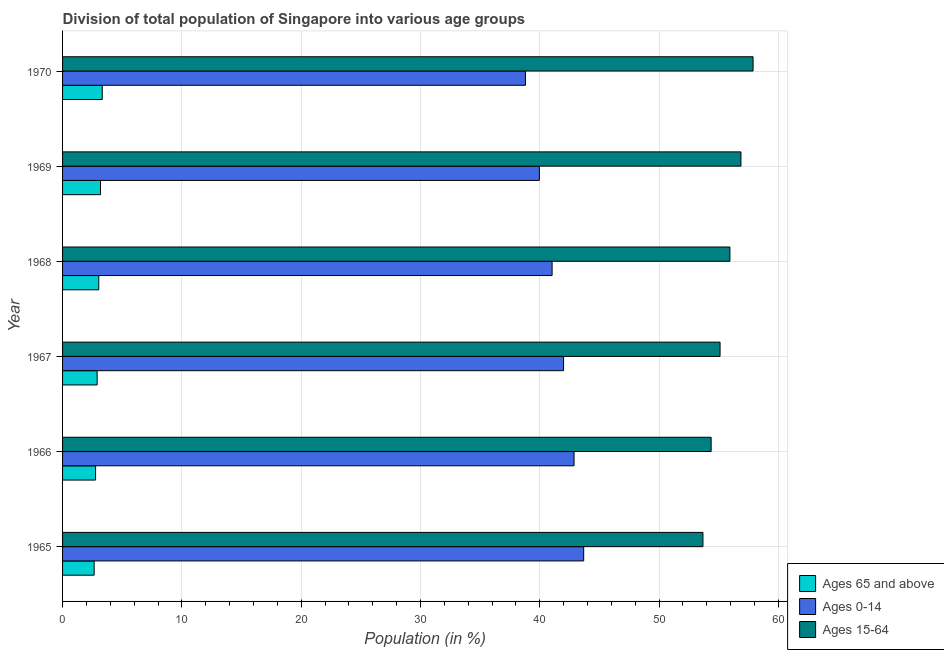How many groups of bars are there?
Give a very brief answer. 6. How many bars are there on the 1st tick from the top?
Your response must be concise. 3. What is the label of the 5th group of bars from the top?
Offer a terse response. 1966. What is the percentage of population within the age-group of 65 and above in 1970?
Make the answer very short. 3.33. Across all years, what is the maximum percentage of population within the age-group of 65 and above?
Offer a terse response. 3.33. Across all years, what is the minimum percentage of population within the age-group 0-14?
Your answer should be compact. 38.8. In which year was the percentage of population within the age-group 15-64 maximum?
Provide a succinct answer. 1970. In which year was the percentage of population within the age-group 0-14 minimum?
Offer a terse response. 1970. What is the total percentage of population within the age-group 0-14 in the graph?
Provide a succinct answer. 248.33. What is the difference between the percentage of population within the age-group 15-64 in 1965 and that in 1967?
Offer a very short reply. -1.44. What is the difference between the percentage of population within the age-group 0-14 in 1967 and the percentage of population within the age-group 15-64 in 1966?
Provide a short and direct response. -12.37. What is the average percentage of population within the age-group 15-64 per year?
Your response must be concise. 55.64. In the year 1967, what is the difference between the percentage of population within the age-group 0-14 and percentage of population within the age-group of 65 and above?
Provide a succinct answer. 39.09. What is the ratio of the percentage of population within the age-group of 65 and above in 1965 to that in 1970?
Your answer should be very brief. 0.8. Is the difference between the percentage of population within the age-group 0-14 in 1968 and 1970 greater than the difference between the percentage of population within the age-group 15-64 in 1968 and 1970?
Your response must be concise. Yes. What is the difference between the highest and the second highest percentage of population within the age-group 0-14?
Your answer should be compact. 0.81. What is the difference between the highest and the lowest percentage of population within the age-group 0-14?
Make the answer very short. 4.88. What does the 2nd bar from the top in 1965 represents?
Your answer should be very brief. Ages 0-14. What does the 3rd bar from the bottom in 1970 represents?
Offer a terse response. Ages 15-64. How many bars are there?
Make the answer very short. 18. How many years are there in the graph?
Offer a very short reply. 6. Does the graph contain grids?
Keep it short and to the point. Yes. Where does the legend appear in the graph?
Offer a terse response. Bottom right. How many legend labels are there?
Ensure brevity in your answer.  3. What is the title of the graph?
Your response must be concise. Division of total population of Singapore into various age groups
. Does "Labor Tax" appear as one of the legend labels in the graph?
Provide a short and direct response. No. What is the label or title of the X-axis?
Provide a succinct answer. Population (in %). What is the Population (in %) in Ages 65 and above in 1965?
Give a very brief answer. 2.65. What is the Population (in %) of Ages 0-14 in 1965?
Make the answer very short. 43.68. What is the Population (in %) of Ages 15-64 in 1965?
Provide a short and direct response. 53.67. What is the Population (in %) in Ages 65 and above in 1966?
Your answer should be compact. 2.77. What is the Population (in %) in Ages 0-14 in 1966?
Your answer should be compact. 42.87. What is the Population (in %) of Ages 15-64 in 1966?
Keep it short and to the point. 54.36. What is the Population (in %) of Ages 65 and above in 1967?
Keep it short and to the point. 2.9. What is the Population (in %) in Ages 0-14 in 1967?
Offer a very short reply. 41.99. What is the Population (in %) in Ages 15-64 in 1967?
Your answer should be very brief. 55.11. What is the Population (in %) in Ages 65 and above in 1968?
Your response must be concise. 3.03. What is the Population (in %) in Ages 0-14 in 1968?
Your answer should be compact. 41.03. What is the Population (in %) in Ages 15-64 in 1968?
Make the answer very short. 55.93. What is the Population (in %) of Ages 65 and above in 1969?
Provide a short and direct response. 3.18. What is the Population (in %) of Ages 0-14 in 1969?
Provide a succinct answer. 39.96. What is the Population (in %) of Ages 15-64 in 1969?
Make the answer very short. 56.86. What is the Population (in %) in Ages 65 and above in 1970?
Provide a short and direct response. 3.33. What is the Population (in %) of Ages 0-14 in 1970?
Offer a very short reply. 38.8. What is the Population (in %) of Ages 15-64 in 1970?
Provide a short and direct response. 57.88. Across all years, what is the maximum Population (in %) in Ages 65 and above?
Offer a very short reply. 3.33. Across all years, what is the maximum Population (in %) in Ages 0-14?
Your response must be concise. 43.68. Across all years, what is the maximum Population (in %) in Ages 15-64?
Make the answer very short. 57.88. Across all years, what is the minimum Population (in %) in Ages 65 and above?
Offer a very short reply. 2.65. Across all years, what is the minimum Population (in %) of Ages 0-14?
Offer a terse response. 38.8. Across all years, what is the minimum Population (in %) of Ages 15-64?
Offer a terse response. 53.67. What is the total Population (in %) in Ages 65 and above in the graph?
Offer a terse response. 17.85. What is the total Population (in %) of Ages 0-14 in the graph?
Provide a short and direct response. 248.33. What is the total Population (in %) in Ages 15-64 in the graph?
Your answer should be compact. 333.81. What is the difference between the Population (in %) of Ages 65 and above in 1965 and that in 1966?
Ensure brevity in your answer.  -0.12. What is the difference between the Population (in %) of Ages 0-14 in 1965 and that in 1966?
Provide a short and direct response. 0.81. What is the difference between the Population (in %) of Ages 15-64 in 1965 and that in 1966?
Your answer should be compact. -0.69. What is the difference between the Population (in %) in Ages 65 and above in 1965 and that in 1967?
Keep it short and to the point. -0.25. What is the difference between the Population (in %) of Ages 0-14 in 1965 and that in 1967?
Offer a very short reply. 1.69. What is the difference between the Population (in %) of Ages 15-64 in 1965 and that in 1967?
Make the answer very short. -1.44. What is the difference between the Population (in %) of Ages 65 and above in 1965 and that in 1968?
Your answer should be compact. -0.39. What is the difference between the Population (in %) in Ages 0-14 in 1965 and that in 1968?
Make the answer very short. 2.65. What is the difference between the Population (in %) of Ages 15-64 in 1965 and that in 1968?
Offer a very short reply. -2.26. What is the difference between the Population (in %) in Ages 65 and above in 1965 and that in 1969?
Ensure brevity in your answer.  -0.53. What is the difference between the Population (in %) in Ages 0-14 in 1965 and that in 1969?
Keep it short and to the point. 3.72. What is the difference between the Population (in %) in Ages 15-64 in 1965 and that in 1969?
Your answer should be very brief. -3.18. What is the difference between the Population (in %) in Ages 65 and above in 1965 and that in 1970?
Offer a terse response. -0.68. What is the difference between the Population (in %) in Ages 0-14 in 1965 and that in 1970?
Provide a short and direct response. 4.88. What is the difference between the Population (in %) in Ages 15-64 in 1965 and that in 1970?
Provide a short and direct response. -4.2. What is the difference between the Population (in %) in Ages 65 and above in 1966 and that in 1967?
Offer a very short reply. -0.13. What is the difference between the Population (in %) in Ages 0-14 in 1966 and that in 1967?
Your response must be concise. 0.88. What is the difference between the Population (in %) in Ages 15-64 in 1966 and that in 1967?
Provide a succinct answer. -0.75. What is the difference between the Population (in %) of Ages 65 and above in 1966 and that in 1968?
Offer a terse response. -0.27. What is the difference between the Population (in %) in Ages 0-14 in 1966 and that in 1968?
Offer a terse response. 1.84. What is the difference between the Population (in %) of Ages 15-64 in 1966 and that in 1968?
Offer a terse response. -1.57. What is the difference between the Population (in %) of Ages 65 and above in 1966 and that in 1969?
Make the answer very short. -0.41. What is the difference between the Population (in %) in Ages 0-14 in 1966 and that in 1969?
Ensure brevity in your answer.  2.91. What is the difference between the Population (in %) in Ages 15-64 in 1966 and that in 1969?
Offer a terse response. -2.5. What is the difference between the Population (in %) of Ages 65 and above in 1966 and that in 1970?
Ensure brevity in your answer.  -0.56. What is the difference between the Population (in %) of Ages 0-14 in 1966 and that in 1970?
Offer a terse response. 4.07. What is the difference between the Population (in %) of Ages 15-64 in 1966 and that in 1970?
Offer a terse response. -3.52. What is the difference between the Population (in %) of Ages 65 and above in 1967 and that in 1968?
Give a very brief answer. -0.14. What is the difference between the Population (in %) in Ages 0-14 in 1967 and that in 1968?
Make the answer very short. 0.96. What is the difference between the Population (in %) of Ages 15-64 in 1967 and that in 1968?
Provide a short and direct response. -0.82. What is the difference between the Population (in %) in Ages 65 and above in 1967 and that in 1969?
Your answer should be very brief. -0.28. What is the difference between the Population (in %) of Ages 0-14 in 1967 and that in 1969?
Your answer should be compact. 2.03. What is the difference between the Population (in %) in Ages 15-64 in 1967 and that in 1969?
Provide a short and direct response. -1.75. What is the difference between the Population (in %) of Ages 65 and above in 1967 and that in 1970?
Offer a very short reply. -0.43. What is the difference between the Population (in %) of Ages 0-14 in 1967 and that in 1970?
Your answer should be compact. 3.2. What is the difference between the Population (in %) of Ages 15-64 in 1967 and that in 1970?
Give a very brief answer. -2.77. What is the difference between the Population (in %) in Ages 65 and above in 1968 and that in 1969?
Your answer should be very brief. -0.14. What is the difference between the Population (in %) in Ages 0-14 in 1968 and that in 1969?
Your answer should be compact. 1.07. What is the difference between the Population (in %) in Ages 15-64 in 1968 and that in 1969?
Ensure brevity in your answer.  -0.93. What is the difference between the Population (in %) in Ages 65 and above in 1968 and that in 1970?
Provide a succinct answer. -0.29. What is the difference between the Population (in %) of Ages 0-14 in 1968 and that in 1970?
Make the answer very short. 2.23. What is the difference between the Population (in %) of Ages 15-64 in 1968 and that in 1970?
Ensure brevity in your answer.  -1.94. What is the difference between the Population (in %) in Ages 65 and above in 1969 and that in 1970?
Give a very brief answer. -0.15. What is the difference between the Population (in %) in Ages 0-14 in 1969 and that in 1970?
Your answer should be compact. 1.17. What is the difference between the Population (in %) in Ages 15-64 in 1969 and that in 1970?
Your response must be concise. -1.02. What is the difference between the Population (in %) of Ages 65 and above in 1965 and the Population (in %) of Ages 0-14 in 1966?
Offer a very short reply. -40.22. What is the difference between the Population (in %) in Ages 65 and above in 1965 and the Population (in %) in Ages 15-64 in 1966?
Offer a terse response. -51.71. What is the difference between the Population (in %) in Ages 0-14 in 1965 and the Population (in %) in Ages 15-64 in 1966?
Keep it short and to the point. -10.68. What is the difference between the Population (in %) in Ages 65 and above in 1965 and the Population (in %) in Ages 0-14 in 1967?
Offer a very short reply. -39.35. What is the difference between the Population (in %) of Ages 65 and above in 1965 and the Population (in %) of Ages 15-64 in 1967?
Ensure brevity in your answer.  -52.46. What is the difference between the Population (in %) in Ages 0-14 in 1965 and the Population (in %) in Ages 15-64 in 1967?
Provide a succinct answer. -11.43. What is the difference between the Population (in %) in Ages 65 and above in 1965 and the Population (in %) in Ages 0-14 in 1968?
Your answer should be compact. -38.38. What is the difference between the Population (in %) of Ages 65 and above in 1965 and the Population (in %) of Ages 15-64 in 1968?
Your response must be concise. -53.29. What is the difference between the Population (in %) of Ages 0-14 in 1965 and the Population (in %) of Ages 15-64 in 1968?
Your answer should be compact. -12.26. What is the difference between the Population (in %) of Ages 65 and above in 1965 and the Population (in %) of Ages 0-14 in 1969?
Give a very brief answer. -37.32. What is the difference between the Population (in %) of Ages 65 and above in 1965 and the Population (in %) of Ages 15-64 in 1969?
Offer a terse response. -54.21. What is the difference between the Population (in %) of Ages 0-14 in 1965 and the Population (in %) of Ages 15-64 in 1969?
Provide a succinct answer. -13.18. What is the difference between the Population (in %) of Ages 65 and above in 1965 and the Population (in %) of Ages 0-14 in 1970?
Offer a terse response. -36.15. What is the difference between the Population (in %) of Ages 65 and above in 1965 and the Population (in %) of Ages 15-64 in 1970?
Give a very brief answer. -55.23. What is the difference between the Population (in %) of Ages 0-14 in 1965 and the Population (in %) of Ages 15-64 in 1970?
Your answer should be compact. -14.2. What is the difference between the Population (in %) of Ages 65 and above in 1966 and the Population (in %) of Ages 0-14 in 1967?
Provide a succinct answer. -39.23. What is the difference between the Population (in %) of Ages 65 and above in 1966 and the Population (in %) of Ages 15-64 in 1967?
Provide a succinct answer. -52.34. What is the difference between the Population (in %) in Ages 0-14 in 1966 and the Population (in %) in Ages 15-64 in 1967?
Ensure brevity in your answer.  -12.24. What is the difference between the Population (in %) of Ages 65 and above in 1966 and the Population (in %) of Ages 0-14 in 1968?
Your answer should be very brief. -38.26. What is the difference between the Population (in %) in Ages 65 and above in 1966 and the Population (in %) in Ages 15-64 in 1968?
Keep it short and to the point. -53.17. What is the difference between the Population (in %) in Ages 0-14 in 1966 and the Population (in %) in Ages 15-64 in 1968?
Your response must be concise. -13.06. What is the difference between the Population (in %) in Ages 65 and above in 1966 and the Population (in %) in Ages 0-14 in 1969?
Give a very brief answer. -37.19. What is the difference between the Population (in %) of Ages 65 and above in 1966 and the Population (in %) of Ages 15-64 in 1969?
Your answer should be compact. -54.09. What is the difference between the Population (in %) of Ages 0-14 in 1966 and the Population (in %) of Ages 15-64 in 1969?
Give a very brief answer. -13.99. What is the difference between the Population (in %) in Ages 65 and above in 1966 and the Population (in %) in Ages 0-14 in 1970?
Keep it short and to the point. -36.03. What is the difference between the Population (in %) of Ages 65 and above in 1966 and the Population (in %) of Ages 15-64 in 1970?
Provide a short and direct response. -55.11. What is the difference between the Population (in %) of Ages 0-14 in 1966 and the Population (in %) of Ages 15-64 in 1970?
Make the answer very short. -15. What is the difference between the Population (in %) in Ages 65 and above in 1967 and the Population (in %) in Ages 0-14 in 1968?
Your response must be concise. -38.13. What is the difference between the Population (in %) of Ages 65 and above in 1967 and the Population (in %) of Ages 15-64 in 1968?
Your answer should be compact. -53.04. What is the difference between the Population (in %) of Ages 0-14 in 1967 and the Population (in %) of Ages 15-64 in 1968?
Offer a very short reply. -13.94. What is the difference between the Population (in %) of Ages 65 and above in 1967 and the Population (in %) of Ages 0-14 in 1969?
Your answer should be very brief. -37.07. What is the difference between the Population (in %) in Ages 65 and above in 1967 and the Population (in %) in Ages 15-64 in 1969?
Offer a terse response. -53.96. What is the difference between the Population (in %) in Ages 0-14 in 1967 and the Population (in %) in Ages 15-64 in 1969?
Provide a succinct answer. -14.87. What is the difference between the Population (in %) in Ages 65 and above in 1967 and the Population (in %) in Ages 0-14 in 1970?
Offer a terse response. -35.9. What is the difference between the Population (in %) of Ages 65 and above in 1967 and the Population (in %) of Ages 15-64 in 1970?
Your response must be concise. -54.98. What is the difference between the Population (in %) in Ages 0-14 in 1967 and the Population (in %) in Ages 15-64 in 1970?
Offer a terse response. -15.88. What is the difference between the Population (in %) of Ages 65 and above in 1968 and the Population (in %) of Ages 0-14 in 1969?
Provide a succinct answer. -36.93. What is the difference between the Population (in %) of Ages 65 and above in 1968 and the Population (in %) of Ages 15-64 in 1969?
Keep it short and to the point. -53.82. What is the difference between the Population (in %) of Ages 0-14 in 1968 and the Population (in %) of Ages 15-64 in 1969?
Offer a very short reply. -15.83. What is the difference between the Population (in %) in Ages 65 and above in 1968 and the Population (in %) in Ages 0-14 in 1970?
Provide a short and direct response. -35.76. What is the difference between the Population (in %) of Ages 65 and above in 1968 and the Population (in %) of Ages 15-64 in 1970?
Offer a terse response. -54.84. What is the difference between the Population (in %) of Ages 0-14 in 1968 and the Population (in %) of Ages 15-64 in 1970?
Keep it short and to the point. -16.84. What is the difference between the Population (in %) in Ages 65 and above in 1969 and the Population (in %) in Ages 0-14 in 1970?
Give a very brief answer. -35.62. What is the difference between the Population (in %) in Ages 65 and above in 1969 and the Population (in %) in Ages 15-64 in 1970?
Make the answer very short. -54.7. What is the difference between the Population (in %) of Ages 0-14 in 1969 and the Population (in %) of Ages 15-64 in 1970?
Your answer should be very brief. -17.91. What is the average Population (in %) of Ages 65 and above per year?
Provide a succinct answer. 2.98. What is the average Population (in %) in Ages 0-14 per year?
Provide a succinct answer. 41.39. What is the average Population (in %) of Ages 15-64 per year?
Keep it short and to the point. 55.64. In the year 1965, what is the difference between the Population (in %) of Ages 65 and above and Population (in %) of Ages 0-14?
Ensure brevity in your answer.  -41.03. In the year 1965, what is the difference between the Population (in %) of Ages 65 and above and Population (in %) of Ages 15-64?
Your answer should be compact. -51.03. In the year 1965, what is the difference between the Population (in %) of Ages 0-14 and Population (in %) of Ages 15-64?
Your answer should be compact. -10. In the year 1966, what is the difference between the Population (in %) of Ages 65 and above and Population (in %) of Ages 0-14?
Provide a short and direct response. -40.1. In the year 1966, what is the difference between the Population (in %) in Ages 65 and above and Population (in %) in Ages 15-64?
Provide a succinct answer. -51.59. In the year 1966, what is the difference between the Population (in %) of Ages 0-14 and Population (in %) of Ages 15-64?
Your answer should be compact. -11.49. In the year 1967, what is the difference between the Population (in %) of Ages 65 and above and Population (in %) of Ages 0-14?
Your answer should be compact. -39.1. In the year 1967, what is the difference between the Population (in %) of Ages 65 and above and Population (in %) of Ages 15-64?
Your answer should be very brief. -52.21. In the year 1967, what is the difference between the Population (in %) in Ages 0-14 and Population (in %) in Ages 15-64?
Give a very brief answer. -13.12. In the year 1968, what is the difference between the Population (in %) of Ages 65 and above and Population (in %) of Ages 0-14?
Provide a short and direct response. -38. In the year 1968, what is the difference between the Population (in %) of Ages 65 and above and Population (in %) of Ages 15-64?
Provide a short and direct response. -52.9. In the year 1968, what is the difference between the Population (in %) in Ages 0-14 and Population (in %) in Ages 15-64?
Keep it short and to the point. -14.9. In the year 1969, what is the difference between the Population (in %) in Ages 65 and above and Population (in %) in Ages 0-14?
Your answer should be compact. -36.78. In the year 1969, what is the difference between the Population (in %) in Ages 65 and above and Population (in %) in Ages 15-64?
Your answer should be compact. -53.68. In the year 1969, what is the difference between the Population (in %) in Ages 0-14 and Population (in %) in Ages 15-64?
Offer a terse response. -16.9. In the year 1970, what is the difference between the Population (in %) of Ages 65 and above and Population (in %) of Ages 0-14?
Provide a succinct answer. -35.47. In the year 1970, what is the difference between the Population (in %) of Ages 65 and above and Population (in %) of Ages 15-64?
Your answer should be compact. -54.55. In the year 1970, what is the difference between the Population (in %) in Ages 0-14 and Population (in %) in Ages 15-64?
Make the answer very short. -19.08. What is the ratio of the Population (in %) of Ages 65 and above in 1965 to that in 1966?
Make the answer very short. 0.96. What is the ratio of the Population (in %) of Ages 0-14 in 1965 to that in 1966?
Your answer should be compact. 1.02. What is the ratio of the Population (in %) in Ages 15-64 in 1965 to that in 1966?
Provide a succinct answer. 0.99. What is the ratio of the Population (in %) in Ages 65 and above in 1965 to that in 1967?
Provide a succinct answer. 0.91. What is the ratio of the Population (in %) in Ages 0-14 in 1965 to that in 1967?
Keep it short and to the point. 1.04. What is the ratio of the Population (in %) of Ages 65 and above in 1965 to that in 1968?
Ensure brevity in your answer.  0.87. What is the ratio of the Population (in %) of Ages 0-14 in 1965 to that in 1968?
Ensure brevity in your answer.  1.06. What is the ratio of the Population (in %) of Ages 15-64 in 1965 to that in 1968?
Your response must be concise. 0.96. What is the ratio of the Population (in %) of Ages 65 and above in 1965 to that in 1969?
Ensure brevity in your answer.  0.83. What is the ratio of the Population (in %) of Ages 0-14 in 1965 to that in 1969?
Provide a short and direct response. 1.09. What is the ratio of the Population (in %) of Ages 15-64 in 1965 to that in 1969?
Offer a terse response. 0.94. What is the ratio of the Population (in %) in Ages 65 and above in 1965 to that in 1970?
Provide a short and direct response. 0.8. What is the ratio of the Population (in %) of Ages 0-14 in 1965 to that in 1970?
Offer a very short reply. 1.13. What is the ratio of the Population (in %) in Ages 15-64 in 1965 to that in 1970?
Your answer should be very brief. 0.93. What is the ratio of the Population (in %) in Ages 65 and above in 1966 to that in 1967?
Offer a terse response. 0.96. What is the ratio of the Population (in %) in Ages 0-14 in 1966 to that in 1967?
Your answer should be compact. 1.02. What is the ratio of the Population (in %) of Ages 15-64 in 1966 to that in 1967?
Your answer should be compact. 0.99. What is the ratio of the Population (in %) of Ages 65 and above in 1966 to that in 1968?
Provide a succinct answer. 0.91. What is the ratio of the Population (in %) of Ages 0-14 in 1966 to that in 1968?
Make the answer very short. 1.04. What is the ratio of the Population (in %) of Ages 15-64 in 1966 to that in 1968?
Give a very brief answer. 0.97. What is the ratio of the Population (in %) in Ages 65 and above in 1966 to that in 1969?
Keep it short and to the point. 0.87. What is the ratio of the Population (in %) of Ages 0-14 in 1966 to that in 1969?
Your answer should be compact. 1.07. What is the ratio of the Population (in %) of Ages 15-64 in 1966 to that in 1969?
Your response must be concise. 0.96. What is the ratio of the Population (in %) in Ages 65 and above in 1966 to that in 1970?
Ensure brevity in your answer.  0.83. What is the ratio of the Population (in %) in Ages 0-14 in 1966 to that in 1970?
Ensure brevity in your answer.  1.1. What is the ratio of the Population (in %) of Ages 15-64 in 1966 to that in 1970?
Your answer should be very brief. 0.94. What is the ratio of the Population (in %) in Ages 65 and above in 1967 to that in 1968?
Your answer should be very brief. 0.95. What is the ratio of the Population (in %) in Ages 0-14 in 1967 to that in 1968?
Give a very brief answer. 1.02. What is the ratio of the Population (in %) of Ages 65 and above in 1967 to that in 1969?
Give a very brief answer. 0.91. What is the ratio of the Population (in %) in Ages 0-14 in 1967 to that in 1969?
Offer a very short reply. 1.05. What is the ratio of the Population (in %) of Ages 15-64 in 1967 to that in 1969?
Offer a very short reply. 0.97. What is the ratio of the Population (in %) in Ages 65 and above in 1967 to that in 1970?
Offer a terse response. 0.87. What is the ratio of the Population (in %) in Ages 0-14 in 1967 to that in 1970?
Provide a short and direct response. 1.08. What is the ratio of the Population (in %) of Ages 15-64 in 1967 to that in 1970?
Give a very brief answer. 0.95. What is the ratio of the Population (in %) of Ages 65 and above in 1968 to that in 1969?
Ensure brevity in your answer.  0.95. What is the ratio of the Population (in %) in Ages 0-14 in 1968 to that in 1969?
Make the answer very short. 1.03. What is the ratio of the Population (in %) of Ages 15-64 in 1968 to that in 1969?
Keep it short and to the point. 0.98. What is the ratio of the Population (in %) in Ages 65 and above in 1968 to that in 1970?
Offer a very short reply. 0.91. What is the ratio of the Population (in %) of Ages 0-14 in 1968 to that in 1970?
Your answer should be very brief. 1.06. What is the ratio of the Population (in %) in Ages 15-64 in 1968 to that in 1970?
Give a very brief answer. 0.97. What is the ratio of the Population (in %) in Ages 65 and above in 1969 to that in 1970?
Your answer should be very brief. 0.96. What is the ratio of the Population (in %) in Ages 0-14 in 1969 to that in 1970?
Provide a short and direct response. 1.03. What is the ratio of the Population (in %) in Ages 15-64 in 1969 to that in 1970?
Offer a terse response. 0.98. What is the difference between the highest and the second highest Population (in %) of Ages 65 and above?
Your response must be concise. 0.15. What is the difference between the highest and the second highest Population (in %) in Ages 0-14?
Provide a succinct answer. 0.81. What is the difference between the highest and the second highest Population (in %) of Ages 15-64?
Make the answer very short. 1.02. What is the difference between the highest and the lowest Population (in %) of Ages 65 and above?
Give a very brief answer. 0.68. What is the difference between the highest and the lowest Population (in %) in Ages 0-14?
Keep it short and to the point. 4.88. What is the difference between the highest and the lowest Population (in %) in Ages 15-64?
Offer a terse response. 4.2. 